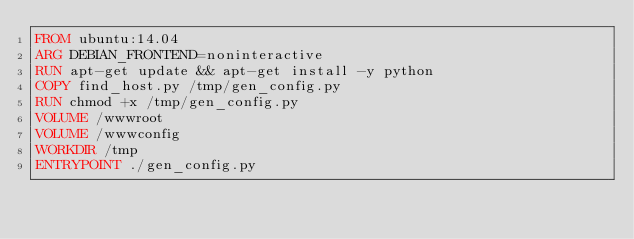Convert code to text. <code><loc_0><loc_0><loc_500><loc_500><_Dockerfile_>FROM ubuntu:14.04
ARG DEBIAN_FRONTEND=noninteractive
RUN apt-get update && apt-get install -y python
COPY find_host.py /tmp/gen_config.py
RUN chmod +x /tmp/gen_config.py
VOLUME /wwwroot
VOLUME /wwwconfig
WORKDIR /tmp
ENTRYPOINT ./gen_config.py</code> 